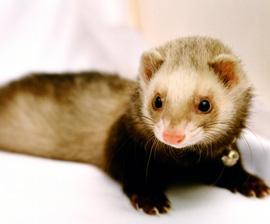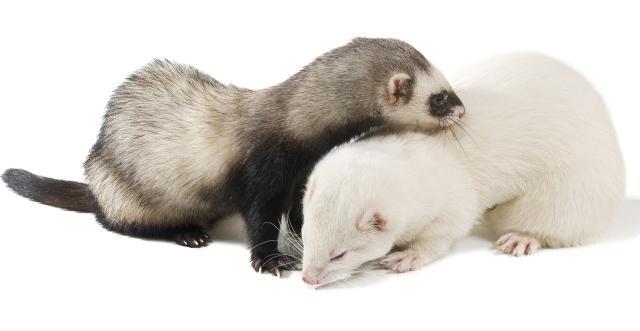The first image is the image on the left, the second image is the image on the right. Considering the images on both sides, is "There are two animals in the image on the right." valid? Answer yes or no. Yes. 